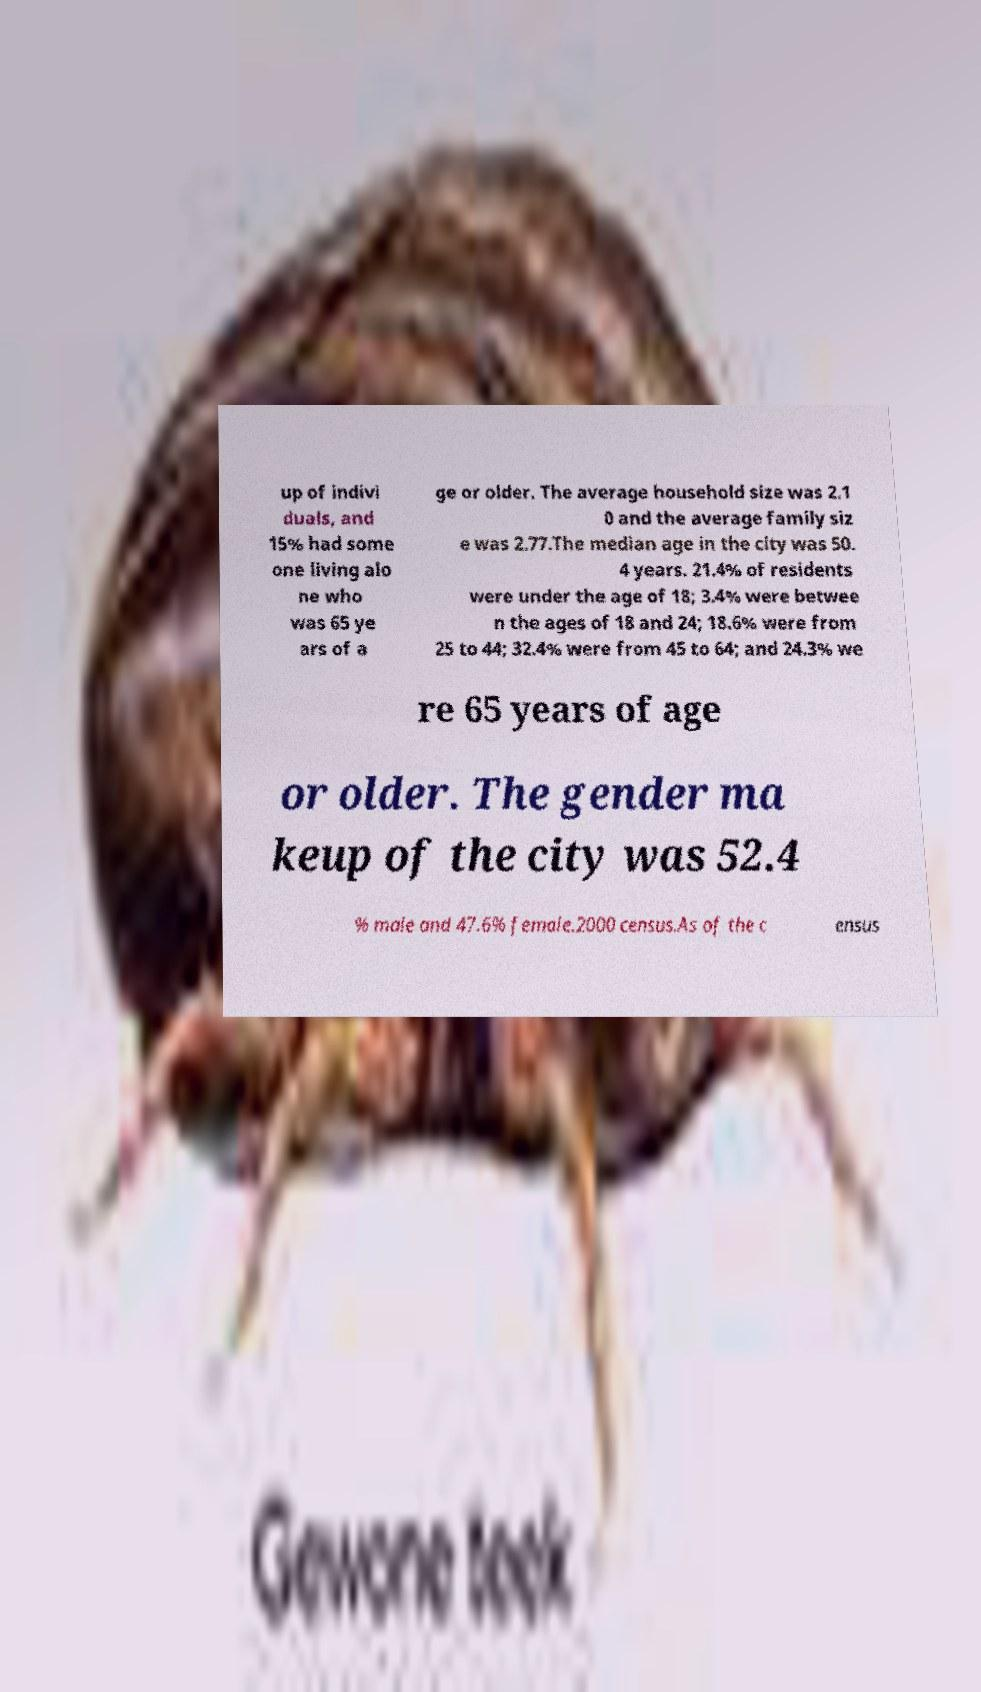I need the written content from this picture converted into text. Can you do that? up of indivi duals, and 15% had some one living alo ne who was 65 ye ars of a ge or older. The average household size was 2.1 0 and the average family siz e was 2.77.The median age in the city was 50. 4 years. 21.4% of residents were under the age of 18; 3.4% were betwee n the ages of 18 and 24; 18.6% were from 25 to 44; 32.4% were from 45 to 64; and 24.3% we re 65 years of age or older. The gender ma keup of the city was 52.4 % male and 47.6% female.2000 census.As of the c ensus 